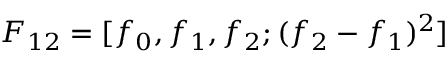Convert formula to latex. <formula><loc_0><loc_0><loc_500><loc_500>F _ { 1 2 } = [ f _ { 0 } , f _ { 1 } , f _ { 2 } ; ( f _ { 2 } - f _ { 1 } ) ^ { 2 } ]</formula> 